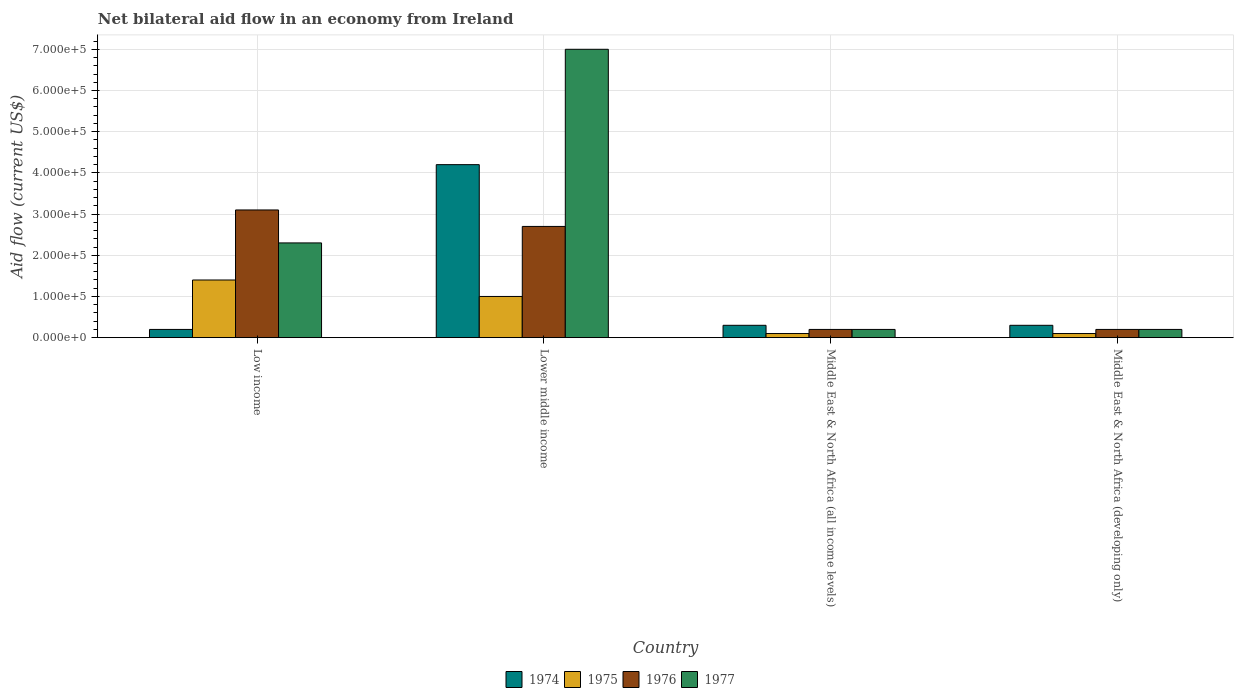How many groups of bars are there?
Your answer should be very brief. 4. What is the label of the 2nd group of bars from the left?
Give a very brief answer. Lower middle income. In how many cases, is the number of bars for a given country not equal to the number of legend labels?
Provide a succinct answer. 0. What is the net bilateral aid flow in 1977 in Lower middle income?
Provide a short and direct response. 7.00e+05. Across all countries, what is the minimum net bilateral aid flow in 1976?
Make the answer very short. 2.00e+04. In which country was the net bilateral aid flow in 1975 maximum?
Ensure brevity in your answer.  Low income. In which country was the net bilateral aid flow in 1976 minimum?
Make the answer very short. Middle East & North Africa (all income levels). What is the total net bilateral aid flow in 1976 in the graph?
Keep it short and to the point. 6.20e+05. What is the difference between the net bilateral aid flow in 1976 in Middle East & North Africa (all income levels) and the net bilateral aid flow in 1975 in Middle East & North Africa (developing only)?
Your response must be concise. 10000. What is the average net bilateral aid flow in 1977 per country?
Offer a very short reply. 2.42e+05. What is the difference between the net bilateral aid flow of/in 1976 and net bilateral aid flow of/in 1975 in Low income?
Ensure brevity in your answer.  1.70e+05. In how many countries, is the net bilateral aid flow in 1977 greater than 620000 US$?
Offer a terse response. 1. What is the ratio of the net bilateral aid flow in 1976 in Low income to that in Lower middle income?
Keep it short and to the point. 1.15. Is the net bilateral aid flow in 1975 in Low income less than that in Lower middle income?
Ensure brevity in your answer.  No. Is the difference between the net bilateral aid flow in 1976 in Low income and Lower middle income greater than the difference between the net bilateral aid flow in 1975 in Low income and Lower middle income?
Your answer should be compact. No. What is the difference between the highest and the second highest net bilateral aid flow in 1975?
Provide a short and direct response. 1.30e+05. What is the difference between the highest and the lowest net bilateral aid flow in 1974?
Provide a succinct answer. 4.00e+05. In how many countries, is the net bilateral aid flow in 1974 greater than the average net bilateral aid flow in 1974 taken over all countries?
Offer a terse response. 1. Is the sum of the net bilateral aid flow in 1974 in Lower middle income and Middle East & North Africa (developing only) greater than the maximum net bilateral aid flow in 1977 across all countries?
Make the answer very short. No. Is it the case that in every country, the sum of the net bilateral aid flow in 1974 and net bilateral aid flow in 1975 is greater than the sum of net bilateral aid flow in 1977 and net bilateral aid flow in 1976?
Ensure brevity in your answer.  No. What does the 3rd bar from the right in Middle East & North Africa (all income levels) represents?
Offer a terse response. 1975. Is it the case that in every country, the sum of the net bilateral aid flow in 1975 and net bilateral aid flow in 1977 is greater than the net bilateral aid flow in 1974?
Offer a terse response. No. Are all the bars in the graph horizontal?
Give a very brief answer. No. How many countries are there in the graph?
Ensure brevity in your answer.  4. Does the graph contain any zero values?
Provide a succinct answer. No. Where does the legend appear in the graph?
Give a very brief answer. Bottom center. How many legend labels are there?
Offer a terse response. 4. How are the legend labels stacked?
Offer a terse response. Horizontal. What is the title of the graph?
Offer a terse response. Net bilateral aid flow in an economy from Ireland. What is the Aid flow (current US$) in 1975 in Low income?
Your answer should be compact. 1.40e+05. What is the Aid flow (current US$) in 1976 in Low income?
Offer a terse response. 3.10e+05. What is the Aid flow (current US$) of 1977 in Low income?
Your answer should be compact. 2.30e+05. What is the Aid flow (current US$) in 1974 in Lower middle income?
Provide a short and direct response. 4.20e+05. What is the Aid flow (current US$) of 1975 in Lower middle income?
Provide a short and direct response. 1.00e+05. What is the Aid flow (current US$) of 1976 in Lower middle income?
Give a very brief answer. 2.70e+05. What is the Aid flow (current US$) in 1975 in Middle East & North Africa (all income levels)?
Offer a very short reply. 10000. What is the Aid flow (current US$) of 1975 in Middle East & North Africa (developing only)?
Your response must be concise. 10000. What is the Aid flow (current US$) of 1976 in Middle East & North Africa (developing only)?
Offer a very short reply. 2.00e+04. What is the Aid flow (current US$) of 1977 in Middle East & North Africa (developing only)?
Your response must be concise. 2.00e+04. Across all countries, what is the maximum Aid flow (current US$) in 1974?
Provide a succinct answer. 4.20e+05. Across all countries, what is the maximum Aid flow (current US$) of 1975?
Make the answer very short. 1.40e+05. Across all countries, what is the maximum Aid flow (current US$) in 1976?
Your answer should be compact. 3.10e+05. Across all countries, what is the minimum Aid flow (current US$) of 1975?
Your answer should be compact. 10000. Across all countries, what is the minimum Aid flow (current US$) of 1977?
Make the answer very short. 2.00e+04. What is the total Aid flow (current US$) in 1974 in the graph?
Ensure brevity in your answer.  5.00e+05. What is the total Aid flow (current US$) in 1975 in the graph?
Provide a short and direct response. 2.60e+05. What is the total Aid flow (current US$) of 1976 in the graph?
Keep it short and to the point. 6.20e+05. What is the total Aid flow (current US$) in 1977 in the graph?
Give a very brief answer. 9.70e+05. What is the difference between the Aid flow (current US$) in 1974 in Low income and that in Lower middle income?
Provide a succinct answer. -4.00e+05. What is the difference between the Aid flow (current US$) in 1975 in Low income and that in Lower middle income?
Provide a short and direct response. 4.00e+04. What is the difference between the Aid flow (current US$) in 1977 in Low income and that in Lower middle income?
Give a very brief answer. -4.70e+05. What is the difference between the Aid flow (current US$) of 1974 in Low income and that in Middle East & North Africa (all income levels)?
Give a very brief answer. -10000. What is the difference between the Aid flow (current US$) in 1975 in Low income and that in Middle East & North Africa (all income levels)?
Give a very brief answer. 1.30e+05. What is the difference between the Aid flow (current US$) in 1974 in Low income and that in Middle East & North Africa (developing only)?
Provide a short and direct response. -10000. What is the difference between the Aid flow (current US$) of 1977 in Low income and that in Middle East & North Africa (developing only)?
Your answer should be compact. 2.10e+05. What is the difference between the Aid flow (current US$) of 1974 in Lower middle income and that in Middle East & North Africa (all income levels)?
Your answer should be very brief. 3.90e+05. What is the difference between the Aid flow (current US$) in 1975 in Lower middle income and that in Middle East & North Africa (all income levels)?
Offer a terse response. 9.00e+04. What is the difference between the Aid flow (current US$) in 1977 in Lower middle income and that in Middle East & North Africa (all income levels)?
Your answer should be very brief. 6.80e+05. What is the difference between the Aid flow (current US$) of 1975 in Lower middle income and that in Middle East & North Africa (developing only)?
Provide a succinct answer. 9.00e+04. What is the difference between the Aid flow (current US$) in 1977 in Lower middle income and that in Middle East & North Africa (developing only)?
Your answer should be very brief. 6.80e+05. What is the difference between the Aid flow (current US$) in 1974 in Middle East & North Africa (all income levels) and that in Middle East & North Africa (developing only)?
Make the answer very short. 0. What is the difference between the Aid flow (current US$) in 1975 in Middle East & North Africa (all income levels) and that in Middle East & North Africa (developing only)?
Offer a very short reply. 0. What is the difference between the Aid flow (current US$) of 1976 in Middle East & North Africa (all income levels) and that in Middle East & North Africa (developing only)?
Keep it short and to the point. 0. What is the difference between the Aid flow (current US$) of 1974 in Low income and the Aid flow (current US$) of 1977 in Lower middle income?
Provide a succinct answer. -6.80e+05. What is the difference between the Aid flow (current US$) in 1975 in Low income and the Aid flow (current US$) in 1977 in Lower middle income?
Give a very brief answer. -5.60e+05. What is the difference between the Aid flow (current US$) of 1976 in Low income and the Aid flow (current US$) of 1977 in Lower middle income?
Offer a very short reply. -3.90e+05. What is the difference between the Aid flow (current US$) in 1974 in Low income and the Aid flow (current US$) in 1975 in Middle East & North Africa (all income levels)?
Your answer should be compact. 10000. What is the difference between the Aid flow (current US$) of 1974 in Low income and the Aid flow (current US$) of 1976 in Middle East & North Africa (all income levels)?
Make the answer very short. 0. What is the difference between the Aid flow (current US$) in 1975 in Low income and the Aid flow (current US$) in 1977 in Middle East & North Africa (all income levels)?
Provide a succinct answer. 1.20e+05. What is the difference between the Aid flow (current US$) in 1976 in Low income and the Aid flow (current US$) in 1977 in Middle East & North Africa (all income levels)?
Your answer should be compact. 2.90e+05. What is the difference between the Aid flow (current US$) in 1974 in Low income and the Aid flow (current US$) in 1977 in Middle East & North Africa (developing only)?
Offer a very short reply. 0. What is the difference between the Aid flow (current US$) of 1975 in Low income and the Aid flow (current US$) of 1977 in Middle East & North Africa (developing only)?
Offer a terse response. 1.20e+05. What is the difference between the Aid flow (current US$) of 1974 in Lower middle income and the Aid flow (current US$) of 1975 in Middle East & North Africa (all income levels)?
Keep it short and to the point. 4.10e+05. What is the difference between the Aid flow (current US$) in 1974 in Lower middle income and the Aid flow (current US$) in 1977 in Middle East & North Africa (all income levels)?
Your answer should be compact. 4.00e+05. What is the difference between the Aid flow (current US$) in 1975 in Lower middle income and the Aid flow (current US$) in 1977 in Middle East & North Africa (all income levels)?
Offer a terse response. 8.00e+04. What is the difference between the Aid flow (current US$) in 1974 in Lower middle income and the Aid flow (current US$) in 1975 in Middle East & North Africa (developing only)?
Offer a terse response. 4.10e+05. What is the difference between the Aid flow (current US$) in 1974 in Lower middle income and the Aid flow (current US$) in 1977 in Middle East & North Africa (developing only)?
Give a very brief answer. 4.00e+05. What is the difference between the Aid flow (current US$) of 1975 in Lower middle income and the Aid flow (current US$) of 1976 in Middle East & North Africa (developing only)?
Offer a terse response. 8.00e+04. What is the difference between the Aid flow (current US$) of 1975 in Lower middle income and the Aid flow (current US$) of 1977 in Middle East & North Africa (developing only)?
Your answer should be very brief. 8.00e+04. What is the difference between the Aid flow (current US$) in 1976 in Lower middle income and the Aid flow (current US$) in 1977 in Middle East & North Africa (developing only)?
Your answer should be very brief. 2.50e+05. What is the difference between the Aid flow (current US$) of 1974 in Middle East & North Africa (all income levels) and the Aid flow (current US$) of 1975 in Middle East & North Africa (developing only)?
Your answer should be very brief. 2.00e+04. What is the difference between the Aid flow (current US$) of 1974 in Middle East & North Africa (all income levels) and the Aid flow (current US$) of 1976 in Middle East & North Africa (developing only)?
Keep it short and to the point. 10000. What is the difference between the Aid flow (current US$) in 1975 in Middle East & North Africa (all income levels) and the Aid flow (current US$) in 1976 in Middle East & North Africa (developing only)?
Keep it short and to the point. -10000. What is the difference between the Aid flow (current US$) in 1975 in Middle East & North Africa (all income levels) and the Aid flow (current US$) in 1977 in Middle East & North Africa (developing only)?
Your answer should be very brief. -10000. What is the average Aid flow (current US$) of 1974 per country?
Provide a succinct answer. 1.25e+05. What is the average Aid flow (current US$) in 1975 per country?
Make the answer very short. 6.50e+04. What is the average Aid flow (current US$) in 1976 per country?
Ensure brevity in your answer.  1.55e+05. What is the average Aid flow (current US$) in 1977 per country?
Your response must be concise. 2.42e+05. What is the difference between the Aid flow (current US$) of 1974 and Aid flow (current US$) of 1977 in Low income?
Make the answer very short. -2.10e+05. What is the difference between the Aid flow (current US$) in 1975 and Aid flow (current US$) in 1977 in Low income?
Offer a very short reply. -9.00e+04. What is the difference between the Aid flow (current US$) in 1976 and Aid flow (current US$) in 1977 in Low income?
Your response must be concise. 8.00e+04. What is the difference between the Aid flow (current US$) in 1974 and Aid flow (current US$) in 1975 in Lower middle income?
Ensure brevity in your answer.  3.20e+05. What is the difference between the Aid flow (current US$) of 1974 and Aid flow (current US$) of 1977 in Lower middle income?
Make the answer very short. -2.80e+05. What is the difference between the Aid flow (current US$) of 1975 and Aid flow (current US$) of 1977 in Lower middle income?
Your answer should be compact. -6.00e+05. What is the difference between the Aid flow (current US$) of 1976 and Aid flow (current US$) of 1977 in Lower middle income?
Give a very brief answer. -4.30e+05. What is the difference between the Aid flow (current US$) of 1974 and Aid flow (current US$) of 1976 in Middle East & North Africa (all income levels)?
Provide a short and direct response. 10000. What is the difference between the Aid flow (current US$) of 1974 and Aid flow (current US$) of 1977 in Middle East & North Africa (all income levels)?
Provide a short and direct response. 10000. What is the difference between the Aid flow (current US$) in 1975 and Aid flow (current US$) in 1977 in Middle East & North Africa (all income levels)?
Provide a succinct answer. -10000. What is the difference between the Aid flow (current US$) in 1976 and Aid flow (current US$) in 1977 in Middle East & North Africa (all income levels)?
Your answer should be very brief. 0. What is the difference between the Aid flow (current US$) of 1974 and Aid flow (current US$) of 1976 in Middle East & North Africa (developing only)?
Your response must be concise. 10000. What is the difference between the Aid flow (current US$) of 1976 and Aid flow (current US$) of 1977 in Middle East & North Africa (developing only)?
Make the answer very short. 0. What is the ratio of the Aid flow (current US$) in 1974 in Low income to that in Lower middle income?
Make the answer very short. 0.05. What is the ratio of the Aid flow (current US$) in 1976 in Low income to that in Lower middle income?
Offer a very short reply. 1.15. What is the ratio of the Aid flow (current US$) of 1977 in Low income to that in Lower middle income?
Offer a terse response. 0.33. What is the ratio of the Aid flow (current US$) of 1974 in Low income to that in Middle East & North Africa (all income levels)?
Your response must be concise. 0.67. What is the ratio of the Aid flow (current US$) in 1975 in Low income to that in Middle East & North Africa (all income levels)?
Offer a terse response. 14. What is the ratio of the Aid flow (current US$) in 1976 in Low income to that in Middle East & North Africa (all income levels)?
Your answer should be compact. 15.5. What is the ratio of the Aid flow (current US$) in 1977 in Low income to that in Middle East & North Africa (all income levels)?
Offer a terse response. 11.5. What is the ratio of the Aid flow (current US$) of 1976 in Low income to that in Middle East & North Africa (developing only)?
Keep it short and to the point. 15.5. What is the ratio of the Aid flow (current US$) in 1977 in Low income to that in Middle East & North Africa (developing only)?
Offer a terse response. 11.5. What is the ratio of the Aid flow (current US$) in 1974 in Lower middle income to that in Middle East & North Africa (all income levels)?
Provide a succinct answer. 14. What is the ratio of the Aid flow (current US$) of 1975 in Lower middle income to that in Middle East & North Africa (all income levels)?
Your response must be concise. 10. What is the ratio of the Aid flow (current US$) of 1976 in Lower middle income to that in Middle East & North Africa (all income levels)?
Give a very brief answer. 13.5. What is the ratio of the Aid flow (current US$) in 1974 in Lower middle income to that in Middle East & North Africa (developing only)?
Your answer should be compact. 14. What is the ratio of the Aid flow (current US$) of 1975 in Lower middle income to that in Middle East & North Africa (developing only)?
Ensure brevity in your answer.  10. What is the ratio of the Aid flow (current US$) in 1976 in Lower middle income to that in Middle East & North Africa (developing only)?
Offer a very short reply. 13.5. What is the ratio of the Aid flow (current US$) in 1975 in Middle East & North Africa (all income levels) to that in Middle East & North Africa (developing only)?
Ensure brevity in your answer.  1. What is the difference between the highest and the second highest Aid flow (current US$) in 1977?
Your response must be concise. 4.70e+05. What is the difference between the highest and the lowest Aid flow (current US$) in 1974?
Offer a terse response. 4.00e+05. What is the difference between the highest and the lowest Aid flow (current US$) of 1975?
Your response must be concise. 1.30e+05. What is the difference between the highest and the lowest Aid flow (current US$) in 1976?
Offer a very short reply. 2.90e+05. What is the difference between the highest and the lowest Aid flow (current US$) of 1977?
Offer a terse response. 6.80e+05. 